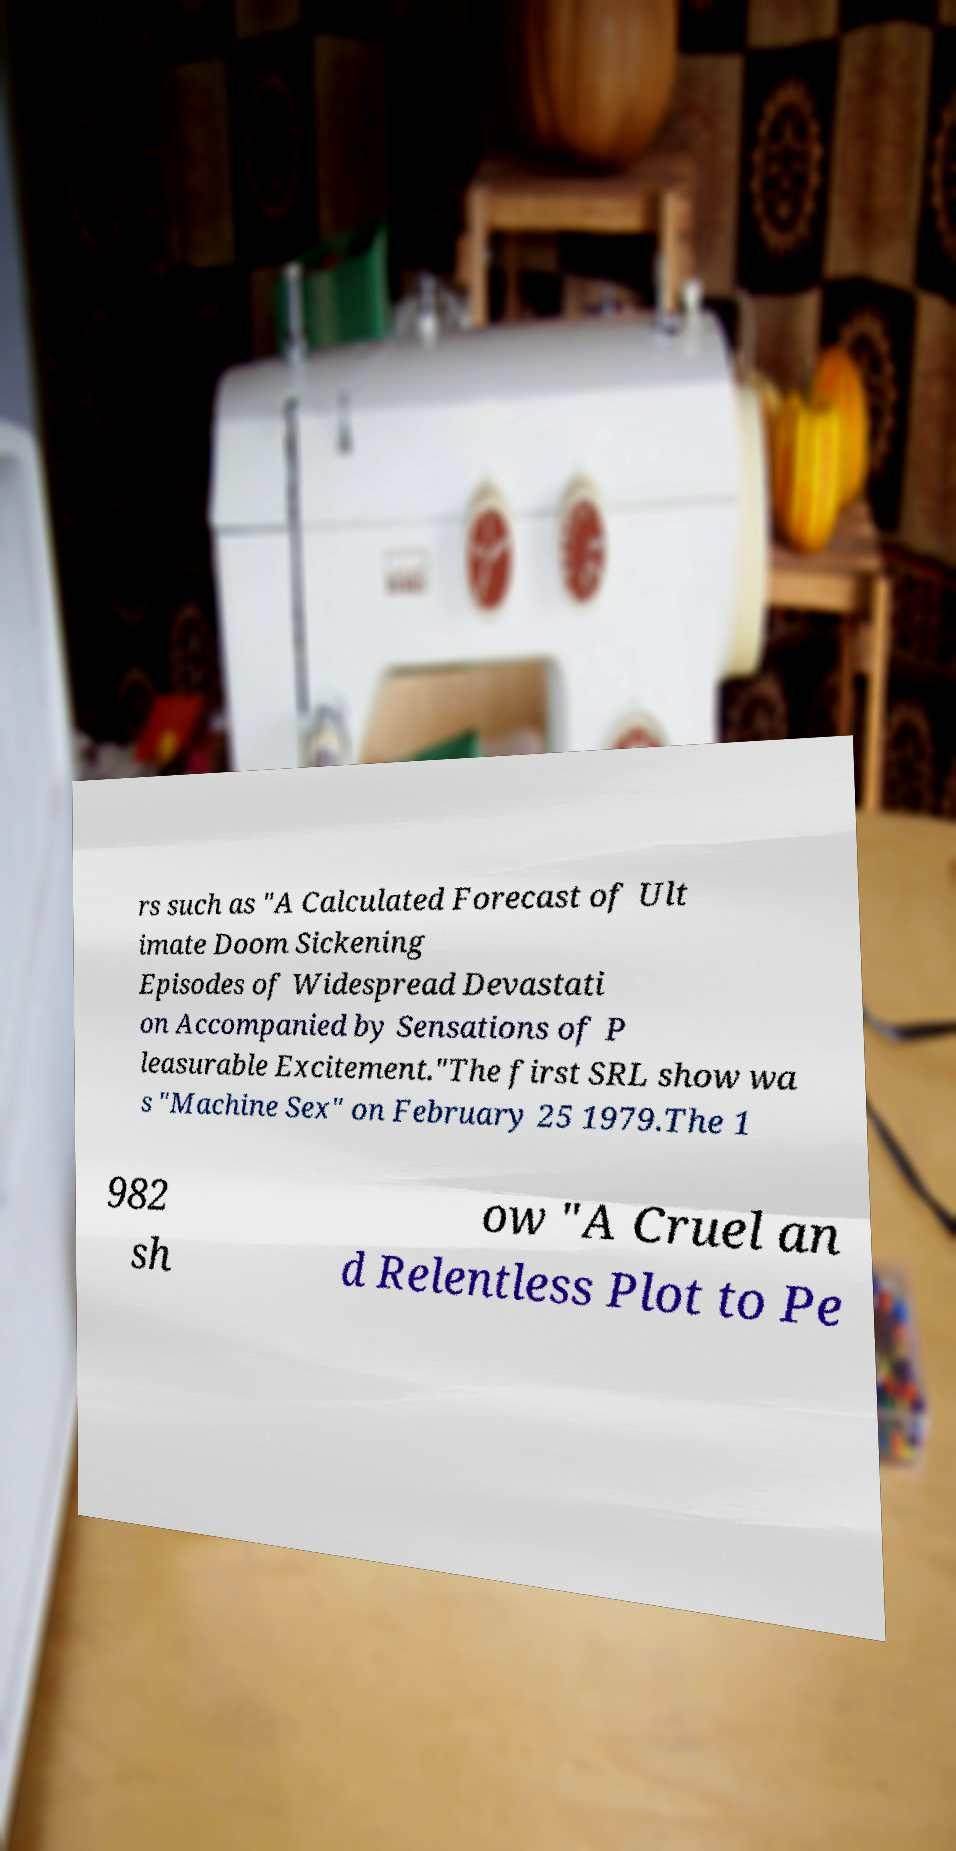What messages or text are displayed in this image? I need them in a readable, typed format. rs such as "A Calculated Forecast of Ult imate Doom Sickening Episodes of Widespread Devastati on Accompanied by Sensations of P leasurable Excitement."The first SRL show wa s "Machine Sex" on February 25 1979.The 1 982 sh ow "A Cruel an d Relentless Plot to Pe 